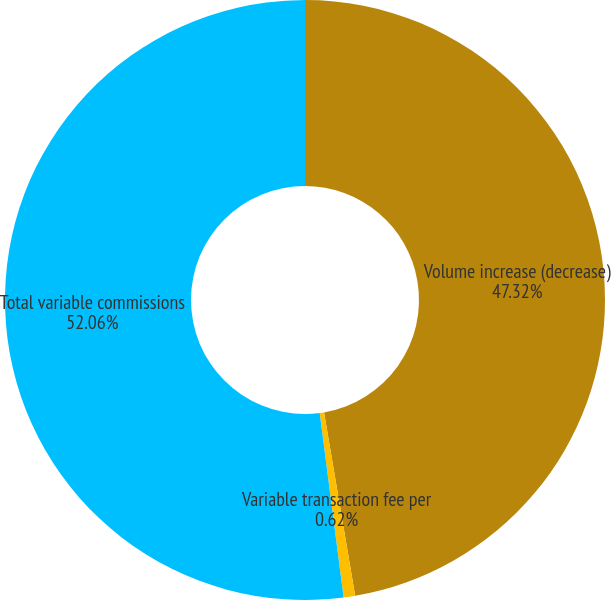Convert chart to OTSL. <chart><loc_0><loc_0><loc_500><loc_500><pie_chart><fcel>Volume increase (decrease)<fcel>Variable transaction fee per<fcel>Total variable commissions<nl><fcel>47.32%<fcel>0.62%<fcel>52.05%<nl></chart> 